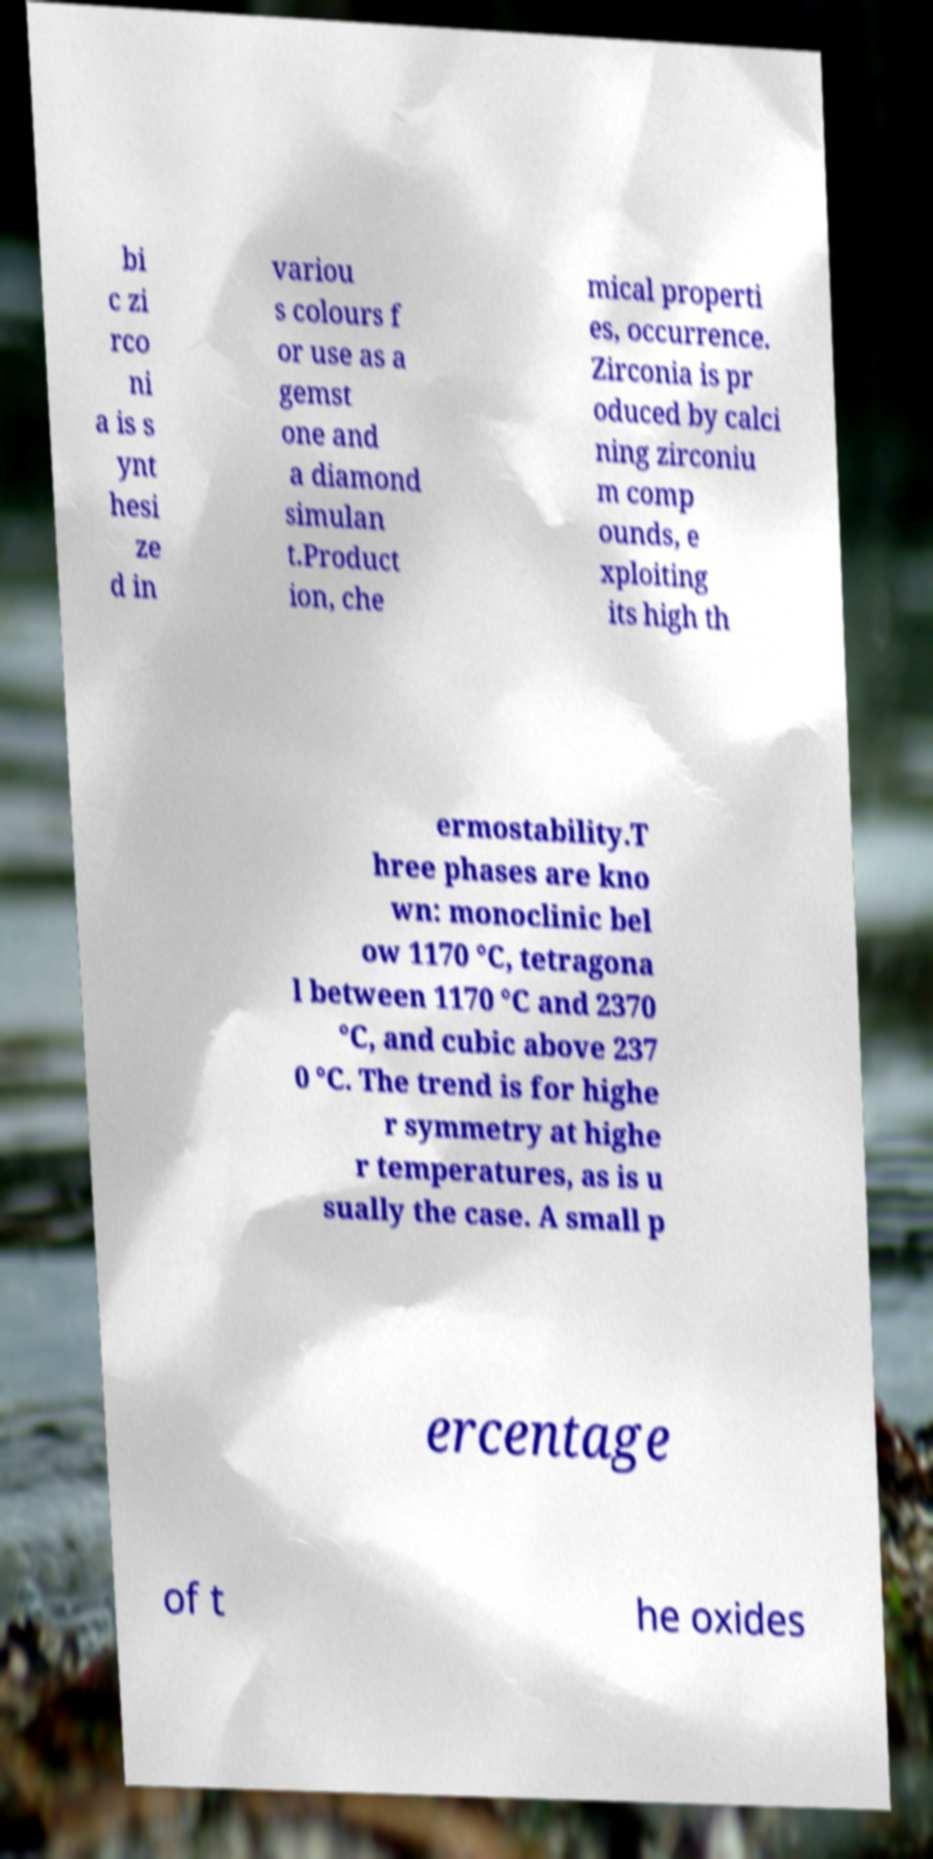Could you assist in decoding the text presented in this image and type it out clearly? bi c zi rco ni a is s ynt hesi ze d in variou s colours f or use as a gemst one and a diamond simulan t.Product ion, che mical properti es, occurrence. Zirconia is pr oduced by calci ning zirconiu m comp ounds, e xploiting its high th ermostability.T hree phases are kno wn: monoclinic bel ow 1170 °C, tetragona l between 1170 °C and 2370 °C, and cubic above 237 0 °C. The trend is for highe r symmetry at highe r temperatures, as is u sually the case. A small p ercentage of t he oxides 